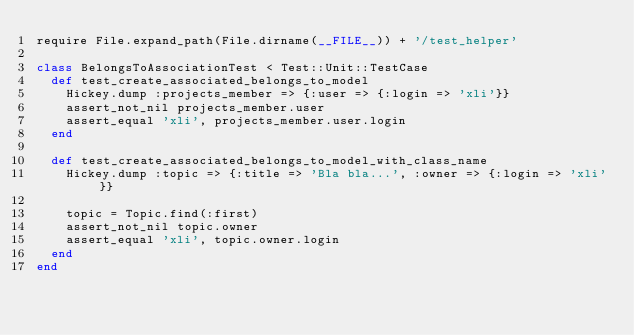Convert code to text. <code><loc_0><loc_0><loc_500><loc_500><_Ruby_>require File.expand_path(File.dirname(__FILE__)) + '/test_helper'

class BelongsToAssociationTest < Test::Unit::TestCase
  def test_create_associated_belongs_to_model
    Hickey.dump :projects_member => {:user => {:login => 'xli'}}
    assert_not_nil projects_member.user
    assert_equal 'xli', projects_member.user.login
  end
  
  def test_create_associated_belongs_to_model_with_class_name
    Hickey.dump :topic => {:title => 'Bla bla...', :owner => {:login => 'xli'}}
    
    topic = Topic.find(:first)
    assert_not_nil topic.owner
    assert_equal 'xli', topic.owner.login
  end
end
</code> 